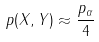<formula> <loc_0><loc_0><loc_500><loc_500>p ( X , Y ) \approx \frac { p _ { \alpha } } { 4 }</formula> 